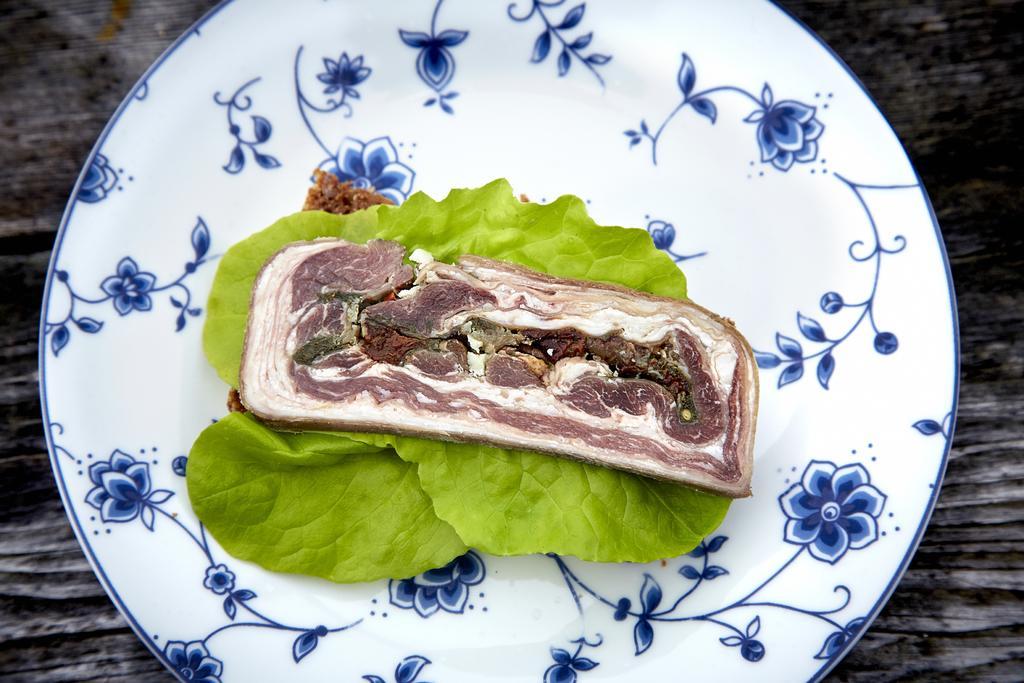Can you describe this image briefly? In this picture we can observe some food places in the white color plate. We can observe green color leaves in the plate. The plate is placed on the black color table. 